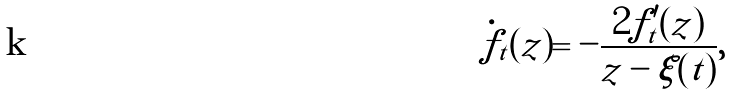<formula> <loc_0><loc_0><loc_500><loc_500>\dot { f } _ { t } ( z ) = - \frac { 2 f _ { t } ^ { \prime } ( z ) } { z - \xi ( t ) } ,</formula> 